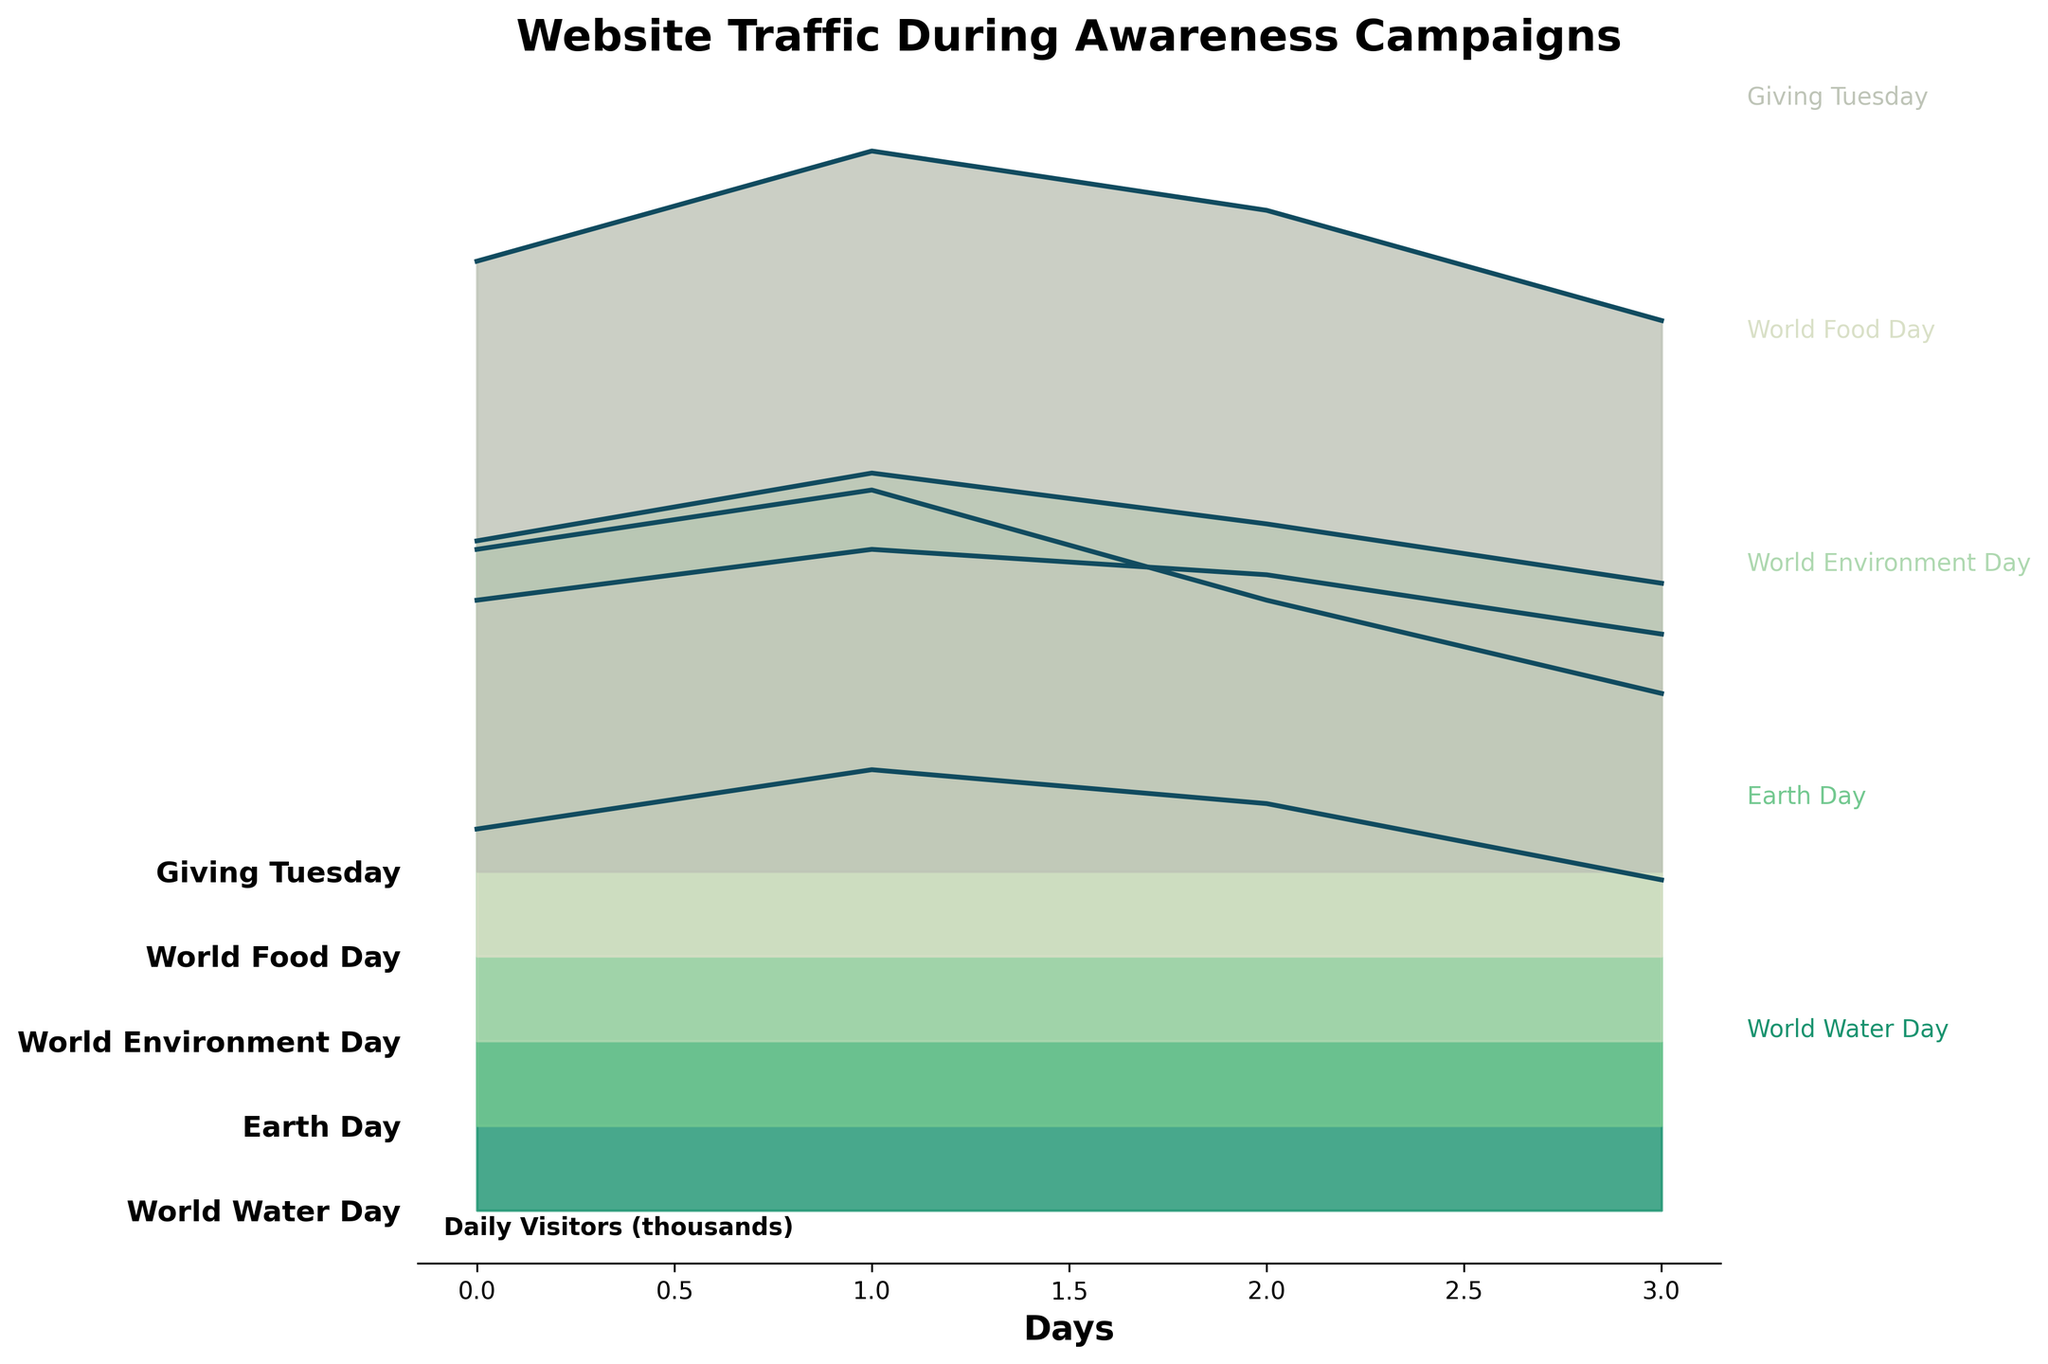What is the title of the plot? The title of the plot is displayed at the top and reads "Website Traffic During Awareness Campaigns".
Answer: Website Traffic During Awareness Campaigns Which awareness campaign displayed the highest website traffic on the first day of tracking? According to the plot, "Giving Tuesday" exhibited the highest website traffic on its first day, as represented by the tallest peak initially.
Answer: Giving Tuesday How many days of data are shown for the "Earth Day" campaign? The plot has four distinct daily data points (peaks) for the "Earth Day" campaign.
Answer: 4 What is the general trend of visitor counts during the "World Food Day" campaign? By observing the "World Food Day" section of the plot, it can be seen that the visitor count starts high on the first day and gradually decreases over the subsequent days.
Answer: Decreasing Compare the peak visitor counts of "World Water Day" and "World Food Day". Which campaign had a higher peak, and by roughly how many visitors? The peak for "World Water Day" is around 5200 visitors, whereas for "World Food Day", it is approximately 4800 visitors. Therefore, "World Water Day" had a higher peak by roughly 400 visitors.
Answer: World Water Day by 400 visitors During which campaign did the website see relatively steady traffic over multiple days, and how can you tell? "World Environment Day" displayed relatively steady visitor numbers. This can be inferred from the plot as the peaks for each day are of similar height, indicating consistent daily visitors.
Answer: World Environment Day How does the website traffic during "Giving Tuesday" compare to "World Water Day" in terms of daily traffic variation? The traffic during "Giving Tuesday" shows more significant fluctuations with higher peaks, while "World Water Day" has smaller variations with less pronounced peaks.
Answer: Giving Tuesday has more fluctuations Which campaigns' peaks lie closest to the y-axis, indicating their occurrence earlier in the year? "World Water Day" (March) and "Earth Day" (April) have peaks that are closest to the y-axis, indicating these campaigns occurred earlier in the year.
Answer: World Water Day and Earth Day What is the average number of daily visitors for the "Earth Day" campaign? The "Earth Day" campaign has the following visitor counts over the four days: 6800, 7500, 6200, and 5100. The average is calculated as (6800 + 7500 + 6200 + 5100)/4 = 6400.
Answer: 6400 How does "World Environment Day" traffic compare to "World Food Day" in terms of consistency, and what indicates this? "World Environment Day" shows more consistent visitor counts with more uniform peaks, while "World Food Day" shows a declining pattern, indicating less consistency. The steady height of the peaks during "World Environment Day" points to more uniform traffic.
Answer: World Environment Day is more consistent 